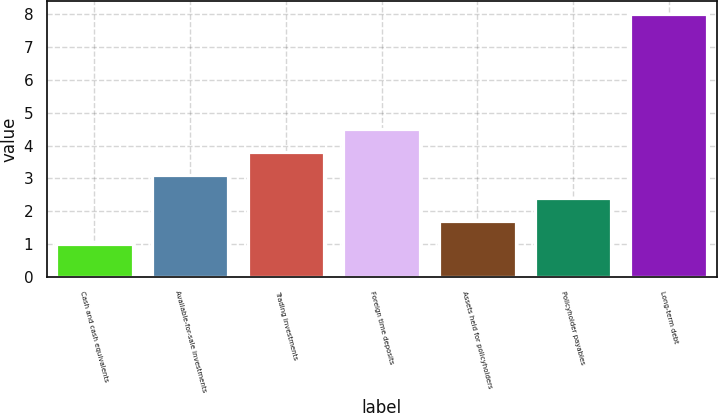Convert chart. <chart><loc_0><loc_0><loc_500><loc_500><bar_chart><fcel>Cash and cash equivalents<fcel>Available-for-sale investments<fcel>Trading investments<fcel>Foreign time deposits<fcel>Assets held for policyholders<fcel>Policyholder payables<fcel>Long-term debt<nl><fcel>1<fcel>3.1<fcel>3.8<fcel>4.5<fcel>1.7<fcel>2.4<fcel>8<nl></chart> 